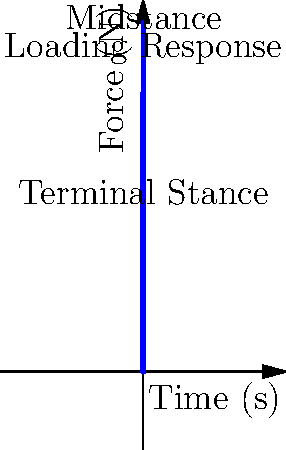Given the force-time curve from a force plate during a single stance phase of gait, identify the peak force (in Newtons) during the midstance phase. How would you implement a MATLAB function to automatically detect this peak? To solve this problem and implement a MATLAB function to detect the peak force during midstance, we can follow these steps:

1. Analyze the given force-time curve:
   - The curve shows three main phases: loading response, midstance, and terminal stance.
   - The midstance phase occurs approximately between 0.4s and 0.6s.

2. Identify the peak force during midstance:
   - By visual inspection, the peak force during midstance is approximately 1000N.

3. Implement a MATLAB function to detect this peak automatically:

   ```matlab
   function peak_force = detect_midstance_peak(time, force)
       % Define the time range for midstance (adjust as needed)
       midstance_start = 0.4;
       midstance_end = 0.6;
       
       % Find indices corresponding to midstance phase
       midstance_indices = find(time >= midstance_start & time <= midstance_end);
       
       % Extract force data for midstance phase
       midstance_force = force(midstance_indices);
       
       % Find the peak force during midstance
       peak_force = max(midstance_force);
   end
   ```

4. This function works as follows:
   a. Define the time range for the midstance phase (adjustable based on gait analysis requirements).
   b. Use the `find` function to get indices of data points within the midstance phase.
   c. Extract the force data for the midstance phase using these indices.
   d. Use the `max` function to find the peak force during midstance.

5. To use this function:
   ```matlab
   time = [0, 0.2, 0.4, 0.6, 0.8, 1.0];
   force = [0, 800, 600, 1000, 400, 0];
   peak = detect_midstance_peak(time, force);
   ```

This approach allows for automatic detection of the midstance peak force, which can be useful for analyzing multiple gait cycles or large datasets efficiently.
Answer: 1000N; Use a MATLAB function to isolate midstance phase data and find its maximum value. 